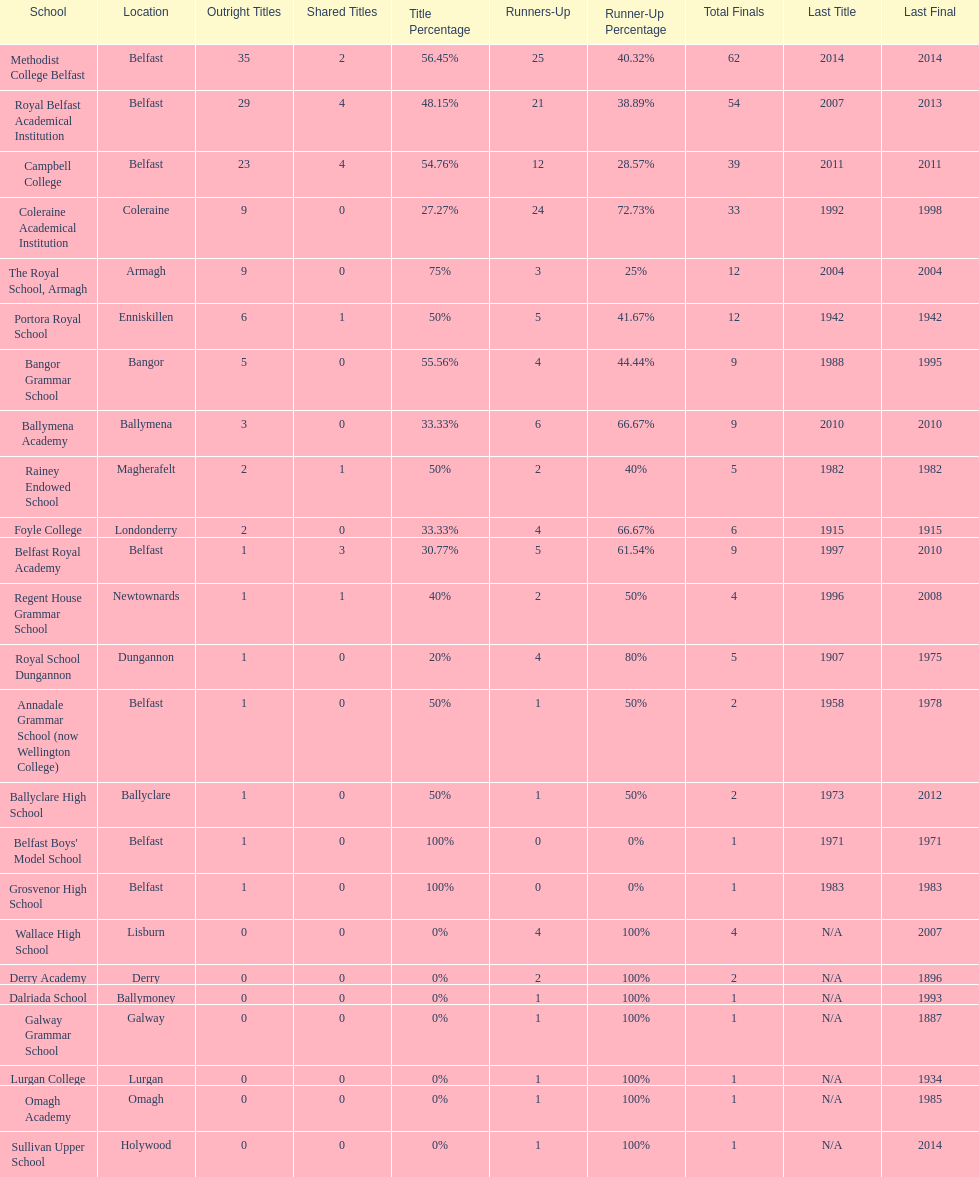Which two schools each had twelve total finals? The Royal School, Armagh, Portora Royal School. 